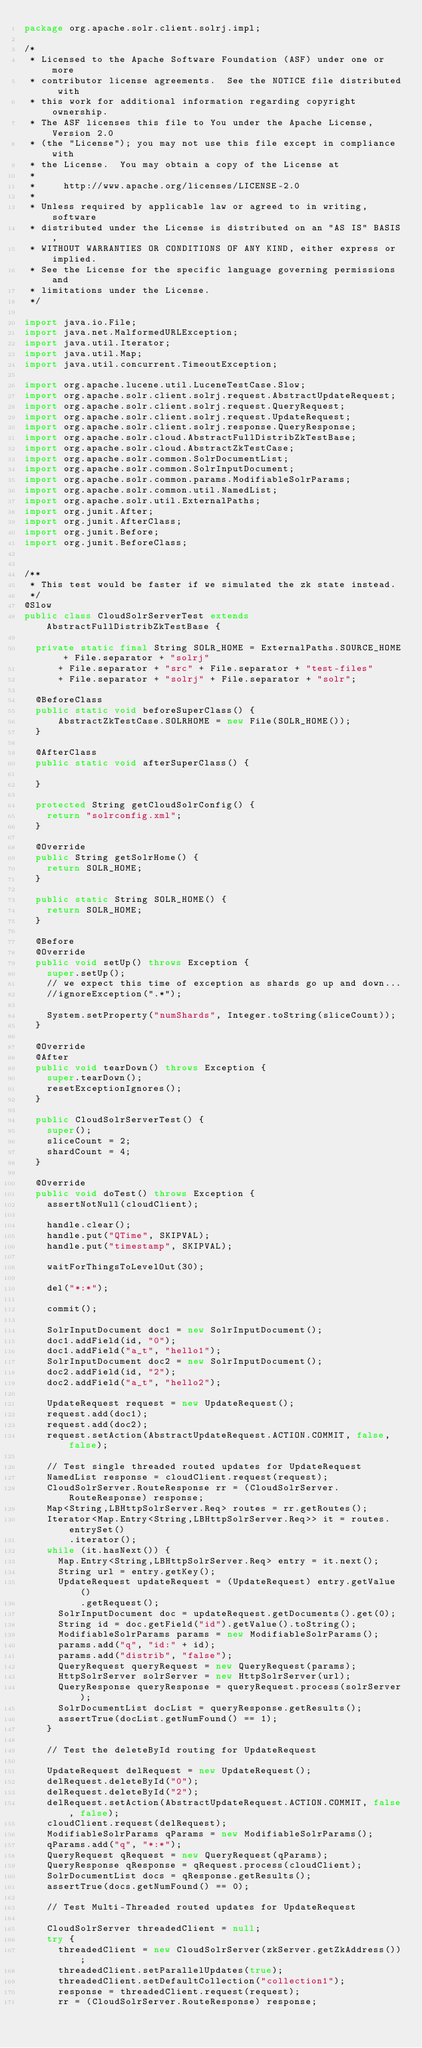Convert code to text. <code><loc_0><loc_0><loc_500><loc_500><_Java_>package org.apache.solr.client.solrj.impl;

/*
 * Licensed to the Apache Software Foundation (ASF) under one or more
 * contributor license agreements.  See the NOTICE file distributed with
 * this work for additional information regarding copyright ownership.
 * The ASF licenses this file to You under the Apache License, Version 2.0
 * (the "License"); you may not use this file except in compliance with
 * the License.  You may obtain a copy of the License at
 *
 *     http://www.apache.org/licenses/LICENSE-2.0
 *
 * Unless required by applicable law or agreed to in writing, software
 * distributed under the License is distributed on an "AS IS" BASIS,
 * WITHOUT WARRANTIES OR CONDITIONS OF ANY KIND, either express or implied.
 * See the License for the specific language governing permissions and
 * limitations under the License.
 */

import java.io.File;
import java.net.MalformedURLException;
import java.util.Iterator;
import java.util.Map;
import java.util.concurrent.TimeoutException;

import org.apache.lucene.util.LuceneTestCase.Slow;
import org.apache.solr.client.solrj.request.AbstractUpdateRequest;
import org.apache.solr.client.solrj.request.QueryRequest;
import org.apache.solr.client.solrj.request.UpdateRequest;
import org.apache.solr.client.solrj.response.QueryResponse;
import org.apache.solr.cloud.AbstractFullDistribZkTestBase;
import org.apache.solr.cloud.AbstractZkTestCase;
import org.apache.solr.common.SolrDocumentList;
import org.apache.solr.common.SolrInputDocument;
import org.apache.solr.common.params.ModifiableSolrParams;
import org.apache.solr.common.util.NamedList;
import org.apache.solr.util.ExternalPaths;
import org.junit.After;
import org.junit.AfterClass;
import org.junit.Before;
import org.junit.BeforeClass;


/**
 * This test would be faster if we simulated the zk state instead.
 */
@Slow
public class CloudSolrServerTest extends AbstractFullDistribZkTestBase {
  
  private static final String SOLR_HOME = ExternalPaths.SOURCE_HOME + File.separator + "solrj"
      + File.separator + "src" + File.separator + "test-files"
      + File.separator + "solrj" + File.separator + "solr";

  @BeforeClass
  public static void beforeSuperClass() {
      AbstractZkTestCase.SOLRHOME = new File(SOLR_HOME());
  }
  
  @AfterClass
  public static void afterSuperClass() {
    
  }
  
  protected String getCloudSolrConfig() {
    return "solrconfig.xml";
  }
  
  @Override
  public String getSolrHome() {
    return SOLR_HOME;
  }
  
  public static String SOLR_HOME() {
    return SOLR_HOME;
  }
  
  @Before
  @Override
  public void setUp() throws Exception {
    super.setUp();
    // we expect this time of exception as shards go up and down...
    //ignoreException(".*");
    
    System.setProperty("numShards", Integer.toString(sliceCount));
  }
  
  @Override
  @After
  public void tearDown() throws Exception {
    super.tearDown();
    resetExceptionIgnores();
  }
  
  public CloudSolrServerTest() {
    super();
    sliceCount = 2;
    shardCount = 4;
  }
  
  @Override
  public void doTest() throws Exception {
    assertNotNull(cloudClient);
    
    handle.clear();
    handle.put("QTime", SKIPVAL);
    handle.put("timestamp", SKIPVAL);
    
    waitForThingsToLevelOut(30);

    del("*:*");

    commit();
    
    SolrInputDocument doc1 = new SolrInputDocument();
    doc1.addField(id, "0");
    doc1.addField("a_t", "hello1");
    SolrInputDocument doc2 = new SolrInputDocument();
    doc2.addField(id, "2");
    doc2.addField("a_t", "hello2");
    
    UpdateRequest request = new UpdateRequest();
    request.add(doc1);
    request.add(doc2);
    request.setAction(AbstractUpdateRequest.ACTION.COMMIT, false, false);
    
    // Test single threaded routed updates for UpdateRequest
    NamedList response = cloudClient.request(request);
    CloudSolrServer.RouteResponse rr = (CloudSolrServer.RouteResponse) response;
    Map<String,LBHttpSolrServer.Req> routes = rr.getRoutes();
    Iterator<Map.Entry<String,LBHttpSolrServer.Req>> it = routes.entrySet()
        .iterator();
    while (it.hasNext()) {
      Map.Entry<String,LBHttpSolrServer.Req> entry = it.next();
      String url = entry.getKey();
      UpdateRequest updateRequest = (UpdateRequest) entry.getValue()
          .getRequest();
      SolrInputDocument doc = updateRequest.getDocuments().get(0);
      String id = doc.getField("id").getValue().toString();
      ModifiableSolrParams params = new ModifiableSolrParams();
      params.add("q", "id:" + id);
      params.add("distrib", "false");
      QueryRequest queryRequest = new QueryRequest(params);
      HttpSolrServer solrServer = new HttpSolrServer(url);
      QueryResponse queryResponse = queryRequest.process(solrServer);
      SolrDocumentList docList = queryResponse.getResults();
      assertTrue(docList.getNumFound() == 1);
    }
    
    // Test the deleteById routing for UpdateRequest
    
    UpdateRequest delRequest = new UpdateRequest();
    delRequest.deleteById("0");
    delRequest.deleteById("2");
    delRequest.setAction(AbstractUpdateRequest.ACTION.COMMIT, false, false);
    cloudClient.request(delRequest);
    ModifiableSolrParams qParams = new ModifiableSolrParams();
    qParams.add("q", "*:*");
    QueryRequest qRequest = new QueryRequest(qParams);
    QueryResponse qResponse = qRequest.process(cloudClient);
    SolrDocumentList docs = qResponse.getResults();
    assertTrue(docs.getNumFound() == 0);
    
    // Test Multi-Threaded routed updates for UpdateRequest
    
    CloudSolrServer threadedClient = null;
    try {
      threadedClient = new CloudSolrServer(zkServer.getZkAddress());
      threadedClient.setParallelUpdates(true);
      threadedClient.setDefaultCollection("collection1");
      response = threadedClient.request(request);
      rr = (CloudSolrServer.RouteResponse) response;</code> 